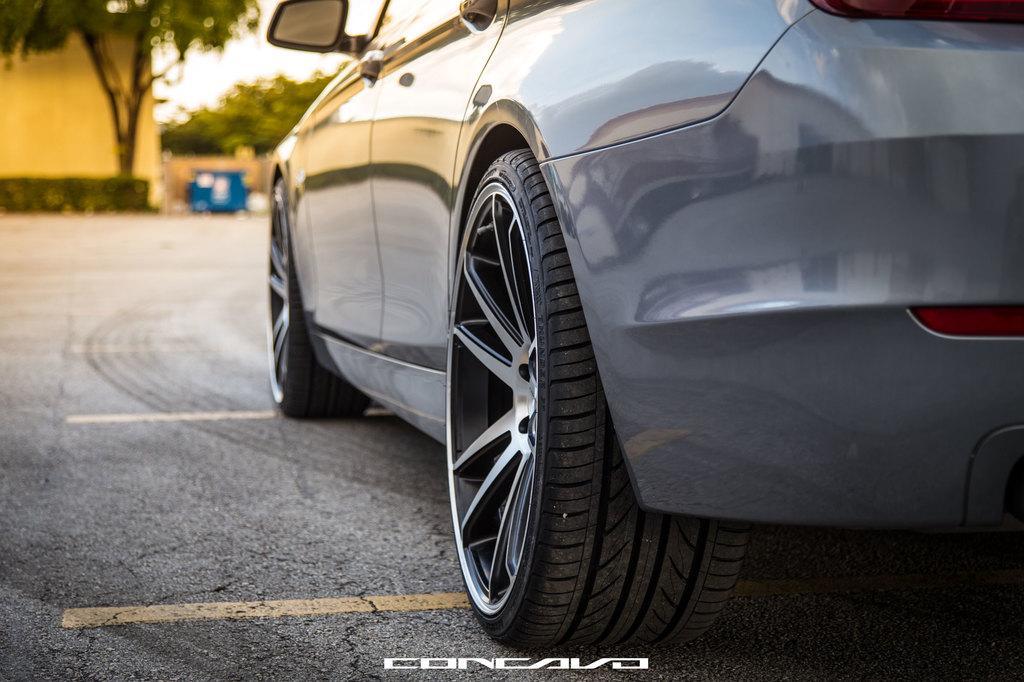Could you give a brief overview of what you see in this image? In this image there is a car on a road, in the background there are trees and it is blurred, at the bottom there is text. 